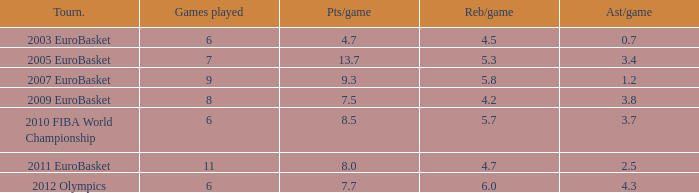How many games played have 4.7 points per game? 1.0. Can you give me this table as a dict? {'header': ['Tourn.', 'Games played', 'Pts/game', 'Reb/game', 'Ast/game'], 'rows': [['2003 EuroBasket', '6', '4.7', '4.5', '0.7'], ['2005 EuroBasket', '7', '13.7', '5.3', '3.4'], ['2007 EuroBasket', '9', '9.3', '5.8', '1.2'], ['2009 EuroBasket', '8', '7.5', '4.2', '3.8'], ['2010 FIBA World Championship', '6', '8.5', '5.7', '3.7'], ['2011 EuroBasket', '11', '8.0', '4.7', '2.5'], ['2012 Olympics', '6', '7.7', '6.0', '4.3']]} 